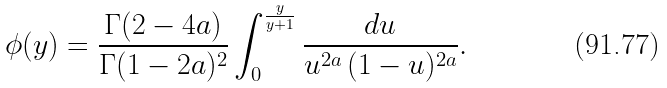<formula> <loc_0><loc_0><loc_500><loc_500>\phi ( y ) = \frac { \Gamma ( 2 - 4 a ) } { \Gamma ( 1 - 2 a ) ^ { 2 } } \int _ { 0 } ^ { \frac { y } { y + 1 } } \frac { d u } { u ^ { 2 a } \, ( 1 - u ) ^ { 2 a } } .</formula> 